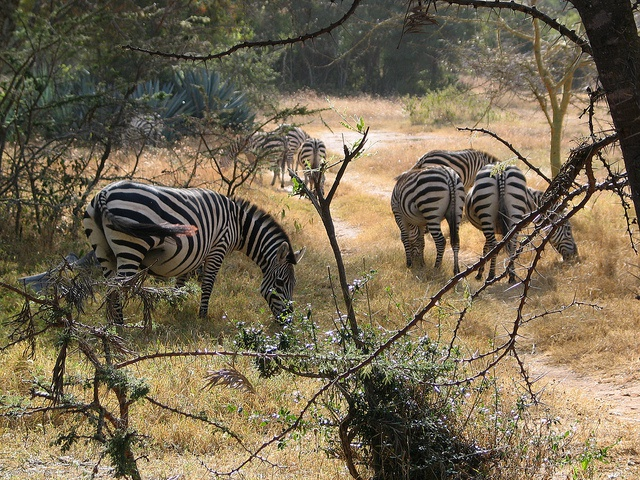Describe the objects in this image and their specific colors. I can see zebra in black, gray, and darkgray tones, zebra in black and gray tones, zebra in black, gray, darkgray, and tan tones, zebra in black and gray tones, and zebra in black and gray tones in this image. 